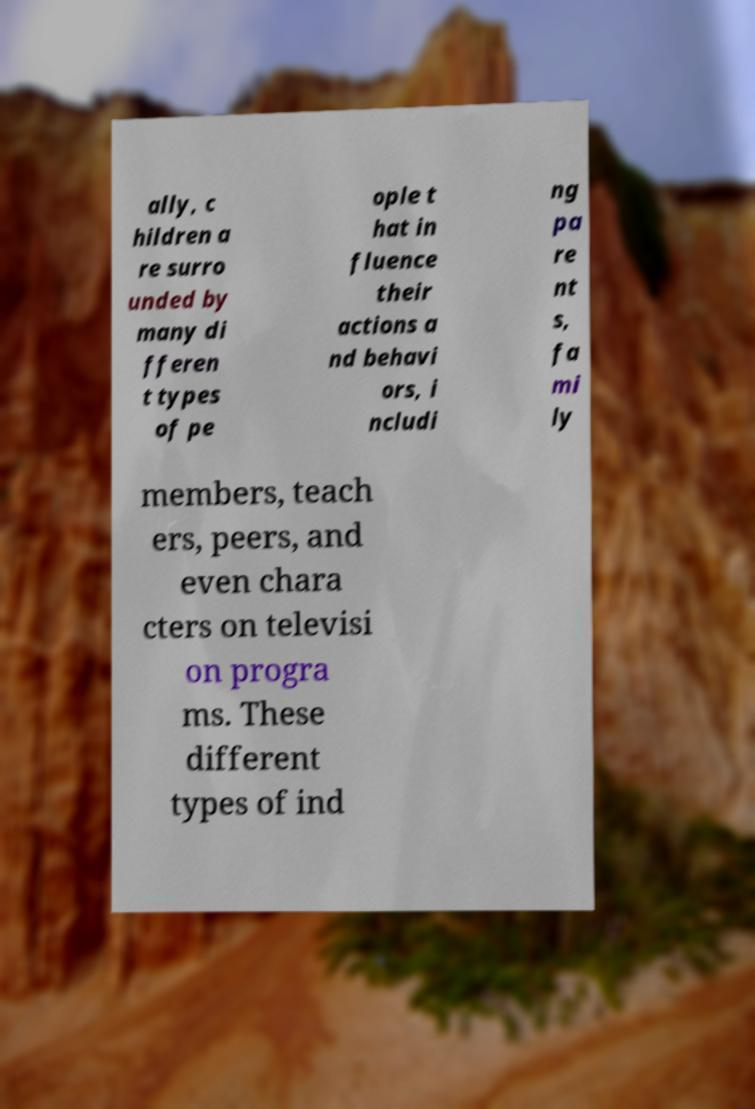Could you assist in decoding the text presented in this image and type it out clearly? ally, c hildren a re surro unded by many di fferen t types of pe ople t hat in fluence their actions a nd behavi ors, i ncludi ng pa re nt s, fa mi ly members, teach ers, peers, and even chara cters on televisi on progra ms. These different types of ind 